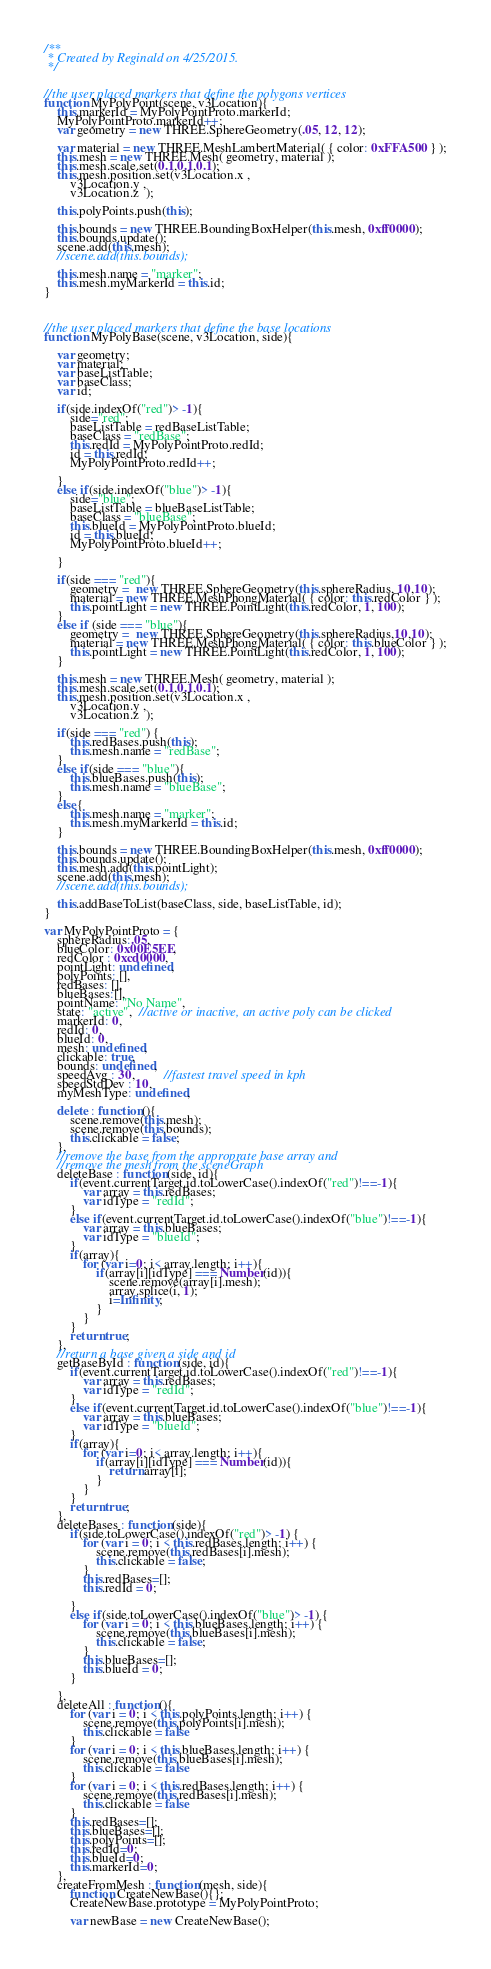Convert code to text. <code><loc_0><loc_0><loc_500><loc_500><_JavaScript_>/**
 * Created by Reginald on 4/25/2015.
 */


//the user placed markers that define the polygons vertices
function MyPolyPoint(scene, v3Location){
    this.markerId = MyPolyPointProto.markerId;
    MyPolyPointProto.markerId++;
    var geometry = new THREE.SphereGeometry(.05, 12, 12);

    var material = new THREE.MeshLambertMaterial( { color: 0xFFA500 } );
    this.mesh = new THREE.Mesh( geometry, material );
    this.mesh.scale.set(0.1,0.1,0.1);
    this.mesh.position.set(v3Location.x ,
        v3Location.y ,
        v3Location.z  );

    this.polyPoints.push(this);

    this.bounds = new THREE.BoundingBoxHelper(this.mesh, 0xff0000);
    this.bounds.update();
    scene.add(this.mesh);
    //scene.add(this.bounds);

    this.mesh.name = "marker";
    this.mesh.myMarkerId = this.id;
}



//the user placed markers that define the base locations
function MyPolyBase(scene, v3Location, side){

    var geometry;
    var material;
    var baseListTable;
    var baseClass;
    var id;

    if(side.indexOf("red")> -1){
        side="red";
        baseListTable = redBaseListTable;
        baseClass = "redBase";
        this.redId = MyPolyPointProto.redId;        
        id = this.redId;
        MyPolyPointProto.redId++;

    }
    else if(side.indexOf("blue")> -1){
        side="blue";
        baseListTable = blueBaseListTable;
        baseClass = "blueBase";
        this.blueId = MyPolyPointProto.blueId;      
        id = this.blueId;
        MyPolyPointProto.blueId++;

    }

    if(side === "red"){
        geometry =  new THREE.SphereGeometry(this.sphereRadius, 10,10);
        material = new THREE.MeshPhongMaterial( { color: this.redColor } );
        this.pointLight = new THREE.PointLight(this.redColor, 1, 100);
    }
    else if (side === "blue"){
        geometry =  new THREE.SphereGeometry(this.sphereRadius,10,10);
        material = new THREE.MeshPhongMaterial( { color: this.blueColor } );
        this.pointLight = new THREE.PointLight(this.redColor, 1, 100);
    }

    this.mesh = new THREE.Mesh( geometry, material );
    this.mesh.scale.set(0.1,0.1,0.1);
    this.mesh.position.set(v3Location.x ,
        v3Location.y ,
        v3Location.z  );

    if(side === "red") {
        this.redBases.push(this);
        this.mesh.name = "redBase";
    }
    else if(side === "blue"){
        this.blueBases.push(this);
        this.mesh.name = "blueBase";
    }
    else{
        this.mesh.name = "marker";
        this.mesh.myMarkerId = this.id;
    }

    this.bounds = new THREE.BoundingBoxHelper(this.mesh, 0xff0000);
    this.bounds.update();
    this.mesh.add(this.pointLight);
    scene.add(this.mesh);
    //scene.add(this.bounds);
    
    this.addBaseToList(baseClass, side, baseListTable, id);
}

var MyPolyPointProto = {
    sphereRadius:.05,
    blueColor: 0x00E5EE,
    redColor : 0xcd0000,
    pointLight: undefined,
    polyPoints: [],
    redBases: [],
    blueBases:[],
    pointName: "No Name",
    state: "active",  //active or inactive, an active poly can be clicked
    markerId: 0,
    redId: 0,
    blueId: 0,
    mesh: undefined,
    clickable: true,
    bounds: undefined,
    speedAvg : 30,         //fastest travel speed in kph
    speedStdDev : 10,
    myMeshType: undefined,

    delete : function(){
        scene.remove(this.mesh);
        scene.remove(this.bounds);
        this.clickable = false;
    },
    //remove the base from the approprate base array and
    //remove the mesh from the sceneGraph
    deleteBase : function(side, id){
        if(event.currentTarget.id.toLowerCase().indexOf("red")!==-1){
            var array = this.redBases;
            var idType = "redId";
        }
        else if(event.currentTarget.id.toLowerCase().indexOf("blue")!==-1){
            var array = this.blueBases;
            var idType = "blueId";
        }
        if(array){
            for (var i=0; i< array.length; i++){
                if(array[i][idType] === Number(id)){
                    scene.remove(array[i].mesh);
                    array.splice(i, 1);
                    i=Infinity;
                }  
            }
        }
        return true;
    },
    //return a base given a side and id
    getBaseById : function(side, id){
        if(event.currentTarget.id.toLowerCase().indexOf("red")!==-1){
            var array = this.redBases;
            var idType = "redId";
        }
        else if(event.currentTarget.id.toLowerCase().indexOf("blue")!==-1){
            var array = this.blueBases;
            var idType = "blueId";
        }
        if(array){
            for (var i=0; i< array.length; i++){
                if(array[i][idType] === Number(id)){
                    return array[i];
                }  
            }
        }
        return true;
    },
    deleteBases : function(side){
        if(side.toLowerCase().indexOf("red")> -1) {
            for (var i = 0; i < this.redBases.length; i++) {
                scene.remove(this.redBases[i].mesh);
                this.clickable = false;
            }
            this.redBases=[];
            this.redId = 0;

        }
        else if(side.toLowerCase().indexOf("blue")> -1) {
            for (var i = 0; i < this.blueBases.length; i++) {
                scene.remove(this.blueBases[i].mesh);
                this.clickable = false;
            }
            this.blueBases=[];
            this.blueId = 0;
        }

    },
    deleteAll : function(){
        for (var i = 0; i < this.polyPoints.length; i++) {
            scene.remove(this.polyPoints[i].mesh);
            this.clickable = false
        }
        for (var i = 0; i < this.blueBases.length; i++) {
            scene.remove(this.blueBases[i].mesh);
            this.clickable = false
        }
        for (var i = 0; i < this.redBases.length; i++) {
            scene.remove(this.redBases[i].mesh);
            this.clickable = false
        }
        this.redBases=[];
        this.blueBases=[];
        this.polyPoints=[];
        this.redId=0;
        this.blueId=0;
        this.markerId=0;
    },
    createFromMesh : function(mesh, side){
        function CreateNewBase(){};
        CreateNewBase.prototype = MyPolyPointProto;

        var newBase = new CreateNewBase();</code> 